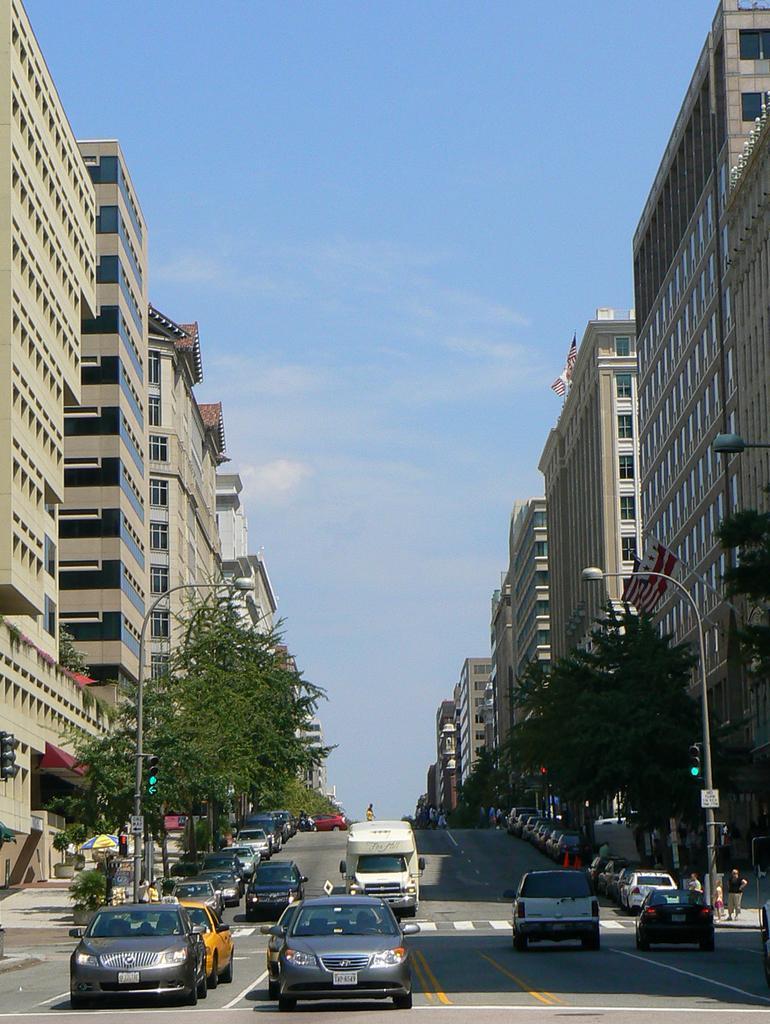Can you describe this image briefly? There are vehicles on the road. Here we can poles, lights, plants, trees, traffic signal, boards, buildings, and few persons. In the background there is sky. 